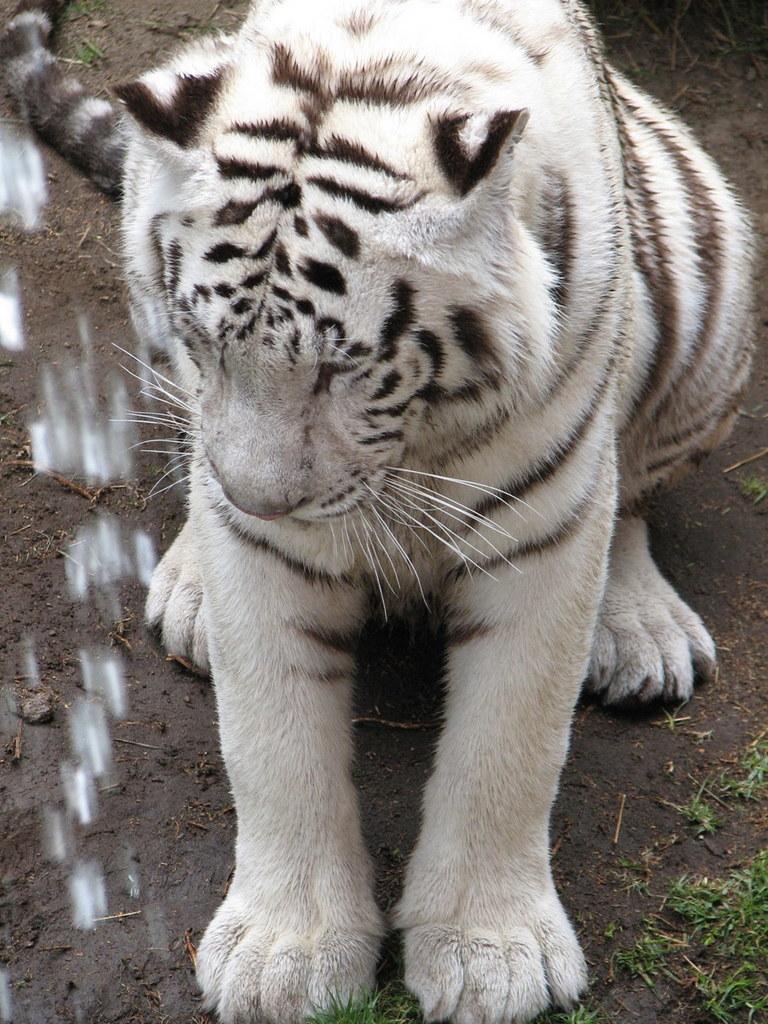Can you describe this image briefly? In this picture we can see a Bengal tiger in the front, at the bottom there is some grass and soil. 